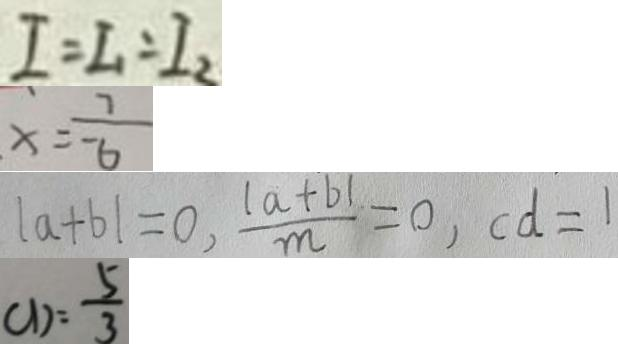<formula> <loc_0><loc_0><loc_500><loc_500>I = I _ { 1 } = I _ { 2 } 
 x = \frac { 7 } { - 6 } 
 \vert a + b \vert = 0 , \frac { \vert a + b \vert } { m } = 0 , c d = 1 
 C D = \frac { 5 } { 3 }</formula> 